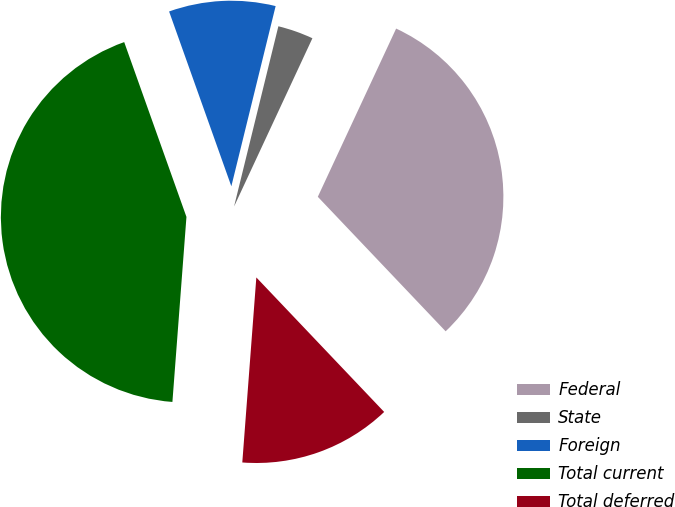Convert chart to OTSL. <chart><loc_0><loc_0><loc_500><loc_500><pie_chart><fcel>Federal<fcel>State<fcel>Foreign<fcel>Total current<fcel>Total deferred<nl><fcel>30.97%<fcel>3.1%<fcel>9.28%<fcel>43.35%<fcel>13.3%<nl></chart> 